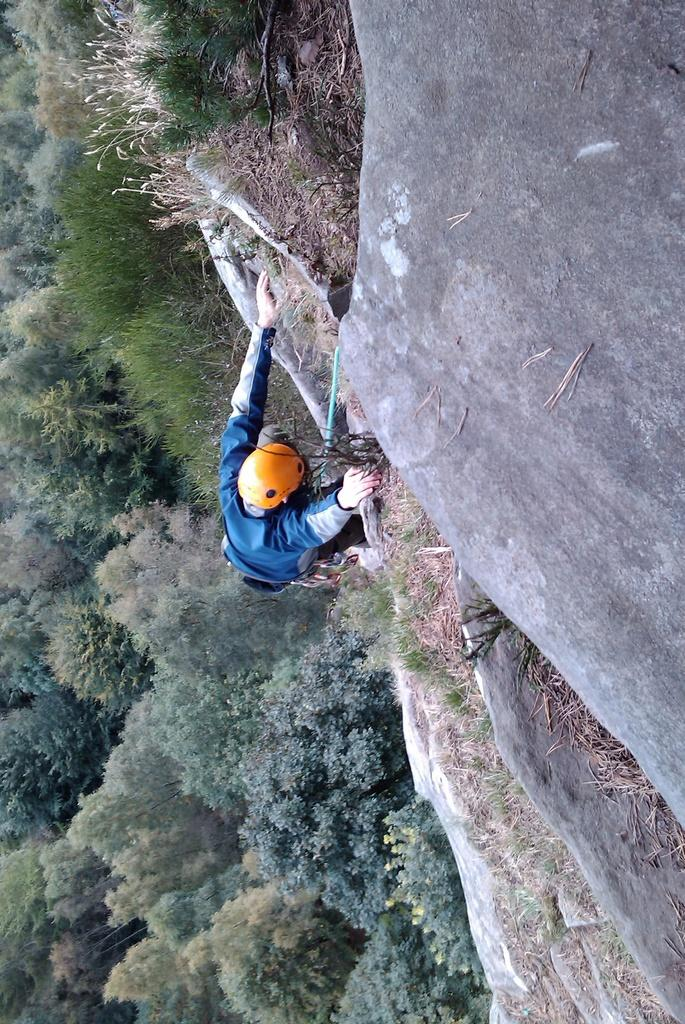Who or what is present in the image? There is a person in the image. What is the person wearing? The person is wearing a blue dress and an orange helmet. What can be seen in the background of the image? There are trees in the background of the image. What is the color of the trees? The trees are green in color. Where is the table located in the image? There is no table present in the image. What type of straw is being used by the person in the image? There is no straw visible in the image. 